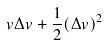Convert formula to latex. <formula><loc_0><loc_0><loc_500><loc_500>v \Delta v + \frac { 1 } { 2 } ( \Delta v ) ^ { 2 }</formula> 